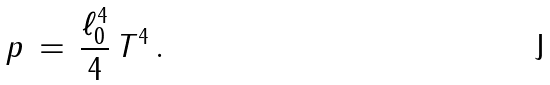Convert formula to latex. <formula><loc_0><loc_0><loc_500><loc_500>p \, = \, \frac { \ell _ { 0 } ^ { 4 } } { 4 } \, T ^ { 4 } \, .</formula> 